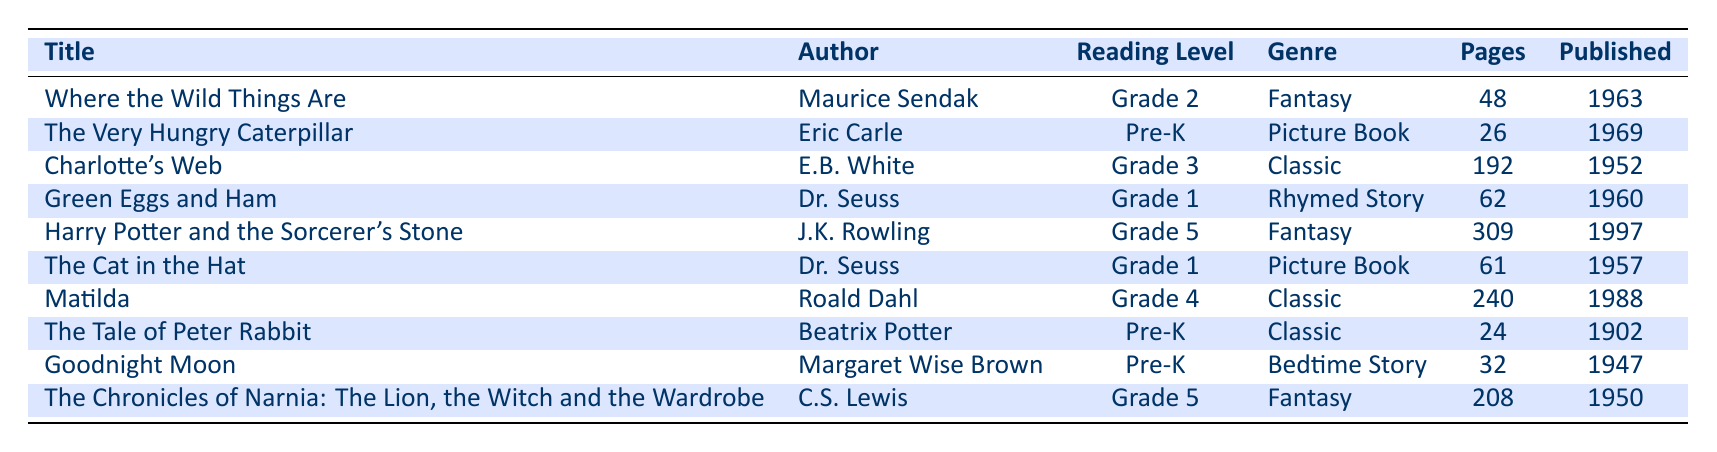What is the reading level of "Charlotte's Web"? "Charlotte's Web" is listed in the table with a reading level of "Grade 3". This information can be directly retrieved from the corresponding row of the table.
Answer: Grade 3 How many pages does "Harry Potter and the Sorcerer's Stone" have? The table shows that "Harry Potter and the Sorcerer's Stone" has 309 pages. This detail is in the specific row of the book.
Answer: 309 Are there more books by Dr. Seuss than by other authors in the table? The table lists two books by Dr. Seuss: "Green Eggs and Ham" and "The Cat in the Hat". Other authors have either one or in the case of E.B. White, two, but no single author surpasses two books. Therefore, there aren't more books by Dr. Seuss than by others, as the maximum found is two.
Answer: No What is the total number of pages for all Pre-K books in the table? The Pre-K books in the table are "The Very Hungry Caterpillar", "The Tale of Peter Rabbit", and "Goodnight Moon" which have pages 26, 24, and 32 respectively. Adding these gives: 26 + 24 + 32 = 82. Thus, the total number of pages is 82.
Answer: 82 Which is the oldest book listed in the table and what year was it published? Examining the "published year" column, "The Tale of Peter Rabbit" was published in 1902, making it the oldest book on the list. This is confirmed by comparing the published years of all the books.
Answer: The Tale of Peter Rabbit, 1902 How many books are categorized as fantasy in the table? The table indicates that there are three books categorized as "Fantasy": "Where the Wild Things Are", "Harry Potter and the Sorcerer's Stone", and "The Chronicles of Narnia: The Lion, the Witch and the Wardrobe". Counting these confirms that there are three fantasy books.
Answer: 3 What is the average number of pages for books at Grade 1 reading level? The Grade 1 books listed are "Green Eggs and Ham" and "The Cat in the Hat". These books have 62 and 61 pages respectively. To find the average, we sum them: 62 + 61 = 123, and divide by 2, yielding an average of 123 / 2 = 61.5.
Answer: 61.5 Is "Matilda" a Classic genre book? The table has "Matilda" categorized under "Classic". This can be confirmed by looking directly in the genre column corresponding to the row for "Matilda".
Answer: Yes Which author has the highest number of pages from their published books in the table? Counting the pages from each author's works, the total pages are: Maurice Sendak (48), Eric Carle (26), E.B. White (192), Dr. Seuss (123), J.K. Rowling (309), Roald Dahl (240), Beatrix Potter (24), Margaret Wise Brown (32), and C.S. Lewis (208). The one with the highest number of pages is J.K. Rowling with 309.
Answer: J.K. Rowling 